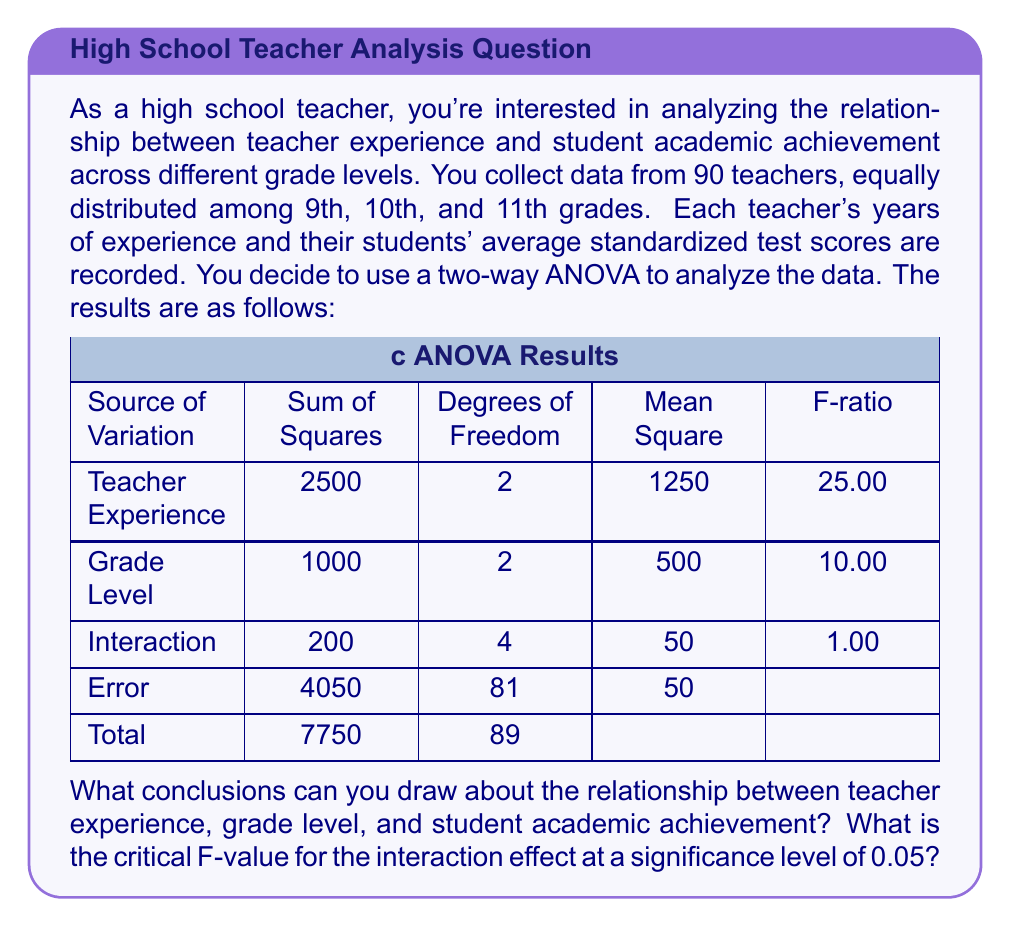Can you answer this question? To interpret the results and draw conclusions, we need to compare the calculated F-ratios with the critical F-values for each effect. Let's go through this step-by-step:

1. Teacher Experience Effect:
   F-ratio = 25.00
   Degrees of freedom: 2 (numerator) and 81 (denominator)
   Critical F-value (α = 0.05): ≈ 3.11

   Since 25.00 > 3.11, we reject the null hypothesis. This suggests that teacher experience has a significant effect on student academic achievement.

2. Grade Level Effect:
   F-ratio = 10.00
   Degrees of freedom: 2 (numerator) and 81 (denominator)
   Critical F-value (α = 0.05): ≈ 3.11

   Since 10.00 > 3.11, we reject the null hypothesis. This indicates that grade level has a significant effect on student academic achievement.

3. Interaction Effect:
   F-ratio = 1.00
   Degrees of freedom: 4 (numerator) and 81 (denominator)
   Critical F-value (α = 0.05): ≈ 2.48

   Since 1.00 < 2.48, we fail to reject the null hypothesis. This suggests that there is no significant interaction between teacher experience and grade level on student academic achievement.

To find the critical F-value for the interaction effect:
- Degrees of freedom: 4 (numerator) and 81 (denominator)
- Significance level: α = 0.05
- Using an F-distribution table or calculator, we find that the critical F-value is approximately 2.48.

Conclusions:
1. Teacher experience has a significant impact on student academic achievement across all grade levels.
2. Grade level also significantly affects student academic achievement.
3. There is no significant interaction between teacher experience and grade level, meaning the effect of teacher experience on student achievement is consistent across different grade levels.

These findings suggest that both teacher experience and grade level are important factors in student academic achievement, but their effects are independent of each other.
Answer: The conclusions are:
1. Teacher experience significantly affects student academic achievement (F = 25.00 > F_crit ≈ 3.11).
2. Grade level significantly affects student academic achievement (F = 10.00 > F_crit ≈ 3.11).
3. There is no significant interaction between teacher experience and grade level (F = 1.00 < F_crit ≈ 2.48).

The critical F-value for the interaction effect at α = 0.05 is approximately 2.48. 